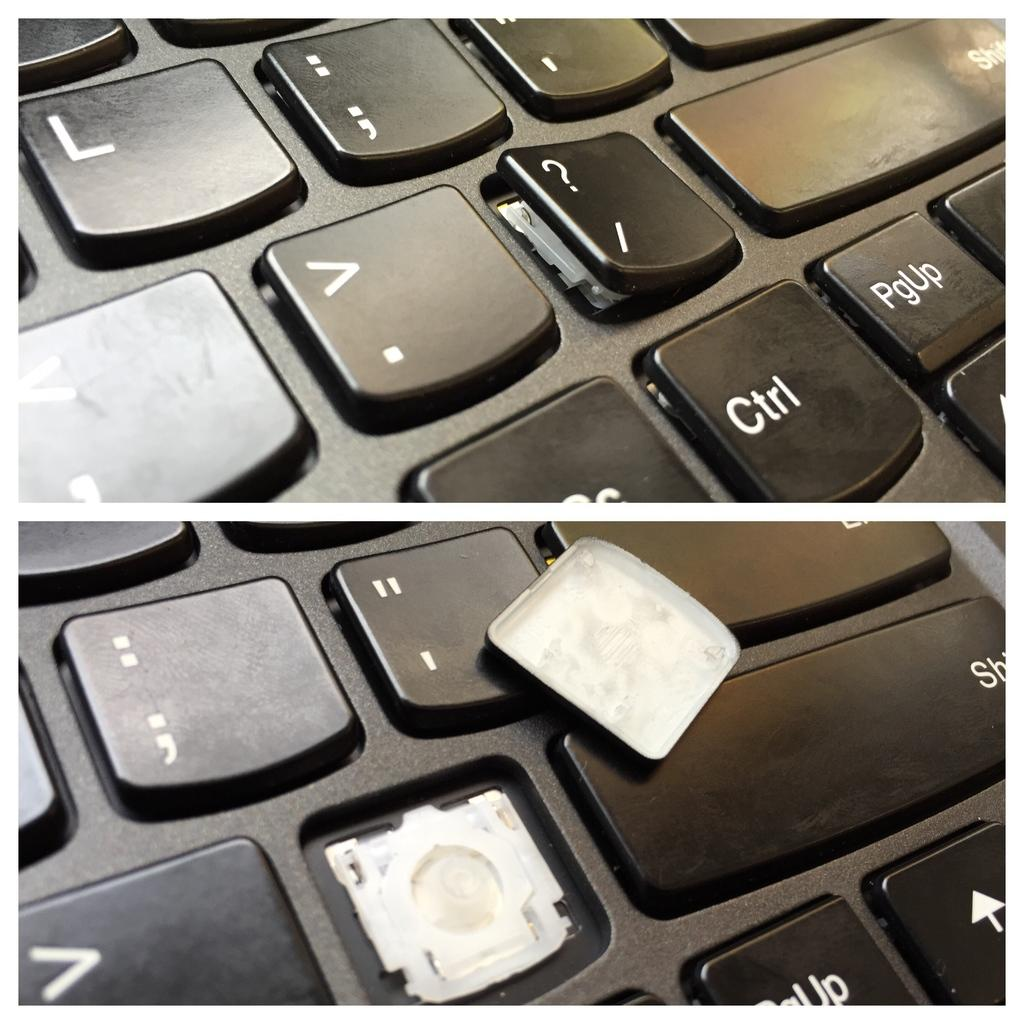Provide a one-sentence caption for the provided image. A keyboard with a broken key next to the shift key. 